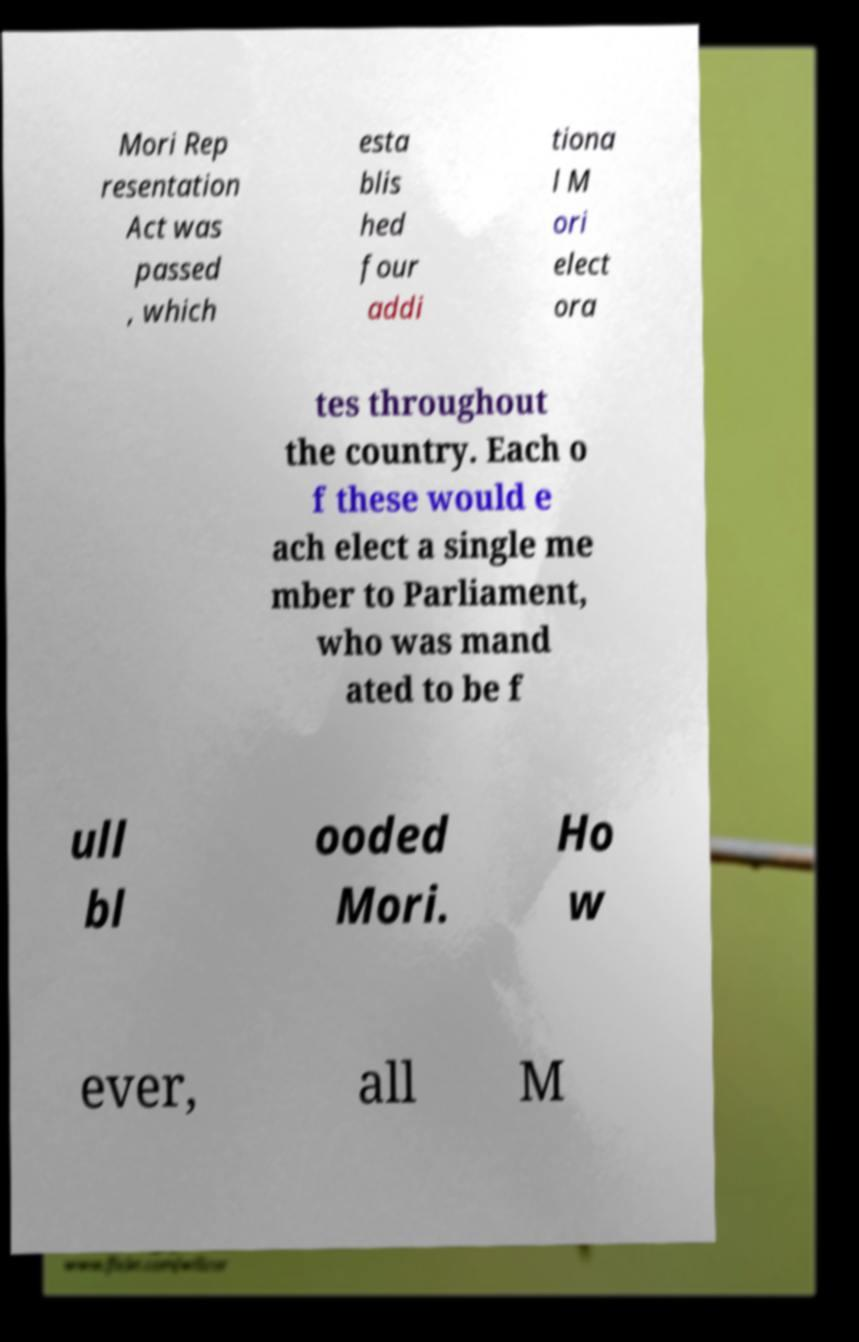Please read and relay the text visible in this image. What does it say? Mori Rep resentation Act was passed , which esta blis hed four addi tiona l M ori elect ora tes throughout the country. Each o f these would e ach elect a single me mber to Parliament, who was mand ated to be f ull bl ooded Mori. Ho w ever, all M 